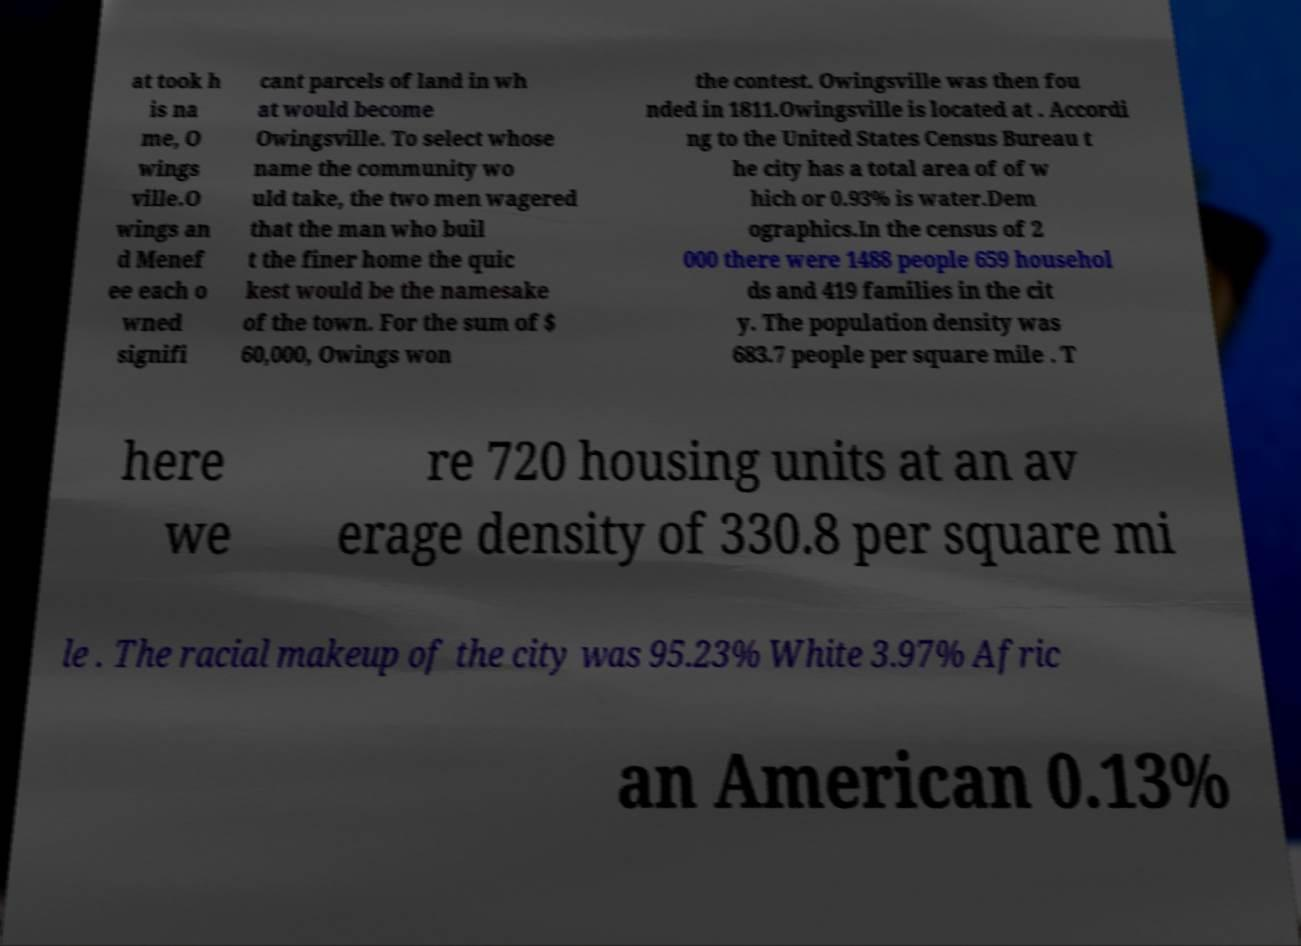Can you accurately transcribe the text from the provided image for me? at took h is na me, O wings ville.O wings an d Menef ee each o wned signifi cant parcels of land in wh at would become Owingsville. To select whose name the community wo uld take, the two men wagered that the man who buil t the finer home the quic kest would be the namesake of the town. For the sum of $ 60,000, Owings won the contest. Owingsville was then fou nded in 1811.Owingsville is located at . Accordi ng to the United States Census Bureau t he city has a total area of of w hich or 0.93% is water.Dem ographics.In the census of 2 000 there were 1488 people 659 househol ds and 419 families in the cit y. The population density was 683.7 people per square mile . T here we re 720 housing units at an av erage density of 330.8 per square mi le . The racial makeup of the city was 95.23% White 3.97% Afric an American 0.13% 